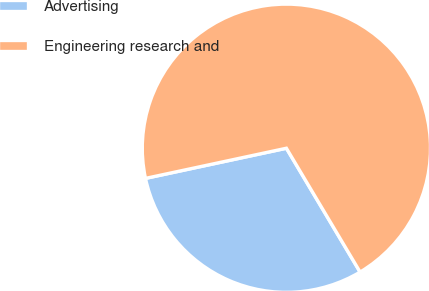<chart> <loc_0><loc_0><loc_500><loc_500><pie_chart><fcel>Advertising<fcel>Engineering research and<nl><fcel>30.19%<fcel>69.81%<nl></chart> 